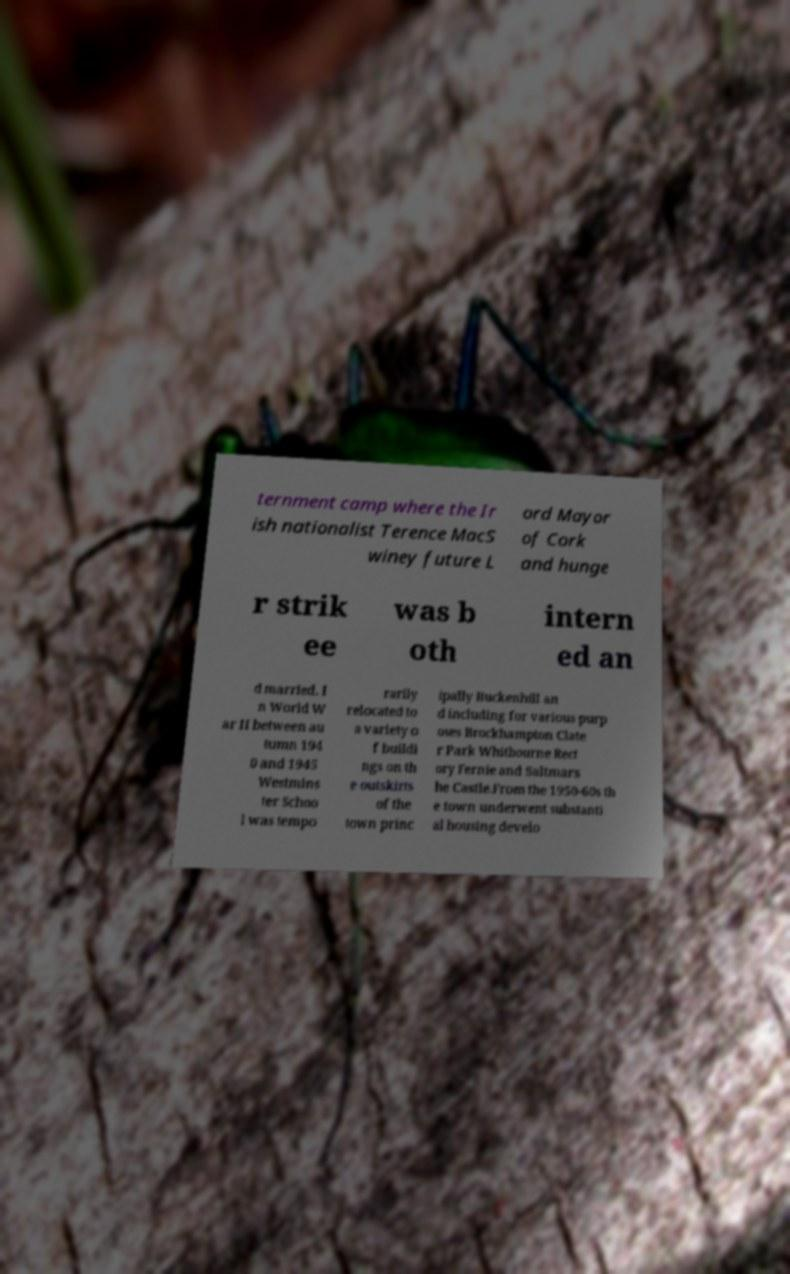Could you assist in decoding the text presented in this image and type it out clearly? ternment camp where the Ir ish nationalist Terence MacS winey future L ord Mayor of Cork and hunge r strik ee was b oth intern ed an d married. I n World W ar II between au tumn 194 0 and 1945 Westmins ter Schoo l was tempo rarily relocated to a variety o f buildi ngs on th e outskirts of the town princ ipally Buckenhill an d including for various purp oses Brockhampton Clate r Park Whitbourne Rect ory Fernie and Saltmars he Castle.From the 1950-60s th e town underwent substanti al housing develo 